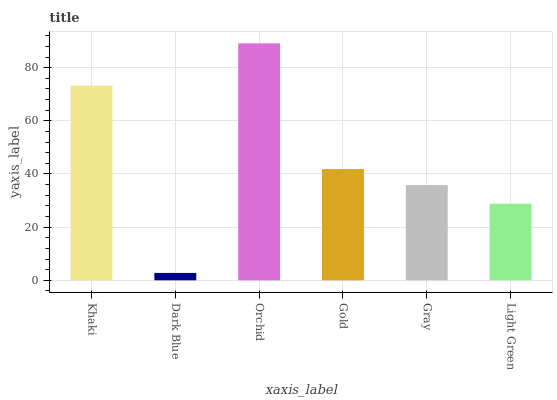Is Dark Blue the minimum?
Answer yes or no. Yes. Is Orchid the maximum?
Answer yes or no. Yes. Is Orchid the minimum?
Answer yes or no. No. Is Dark Blue the maximum?
Answer yes or no. No. Is Orchid greater than Dark Blue?
Answer yes or no. Yes. Is Dark Blue less than Orchid?
Answer yes or no. Yes. Is Dark Blue greater than Orchid?
Answer yes or no. No. Is Orchid less than Dark Blue?
Answer yes or no. No. Is Gold the high median?
Answer yes or no. Yes. Is Gray the low median?
Answer yes or no. Yes. Is Orchid the high median?
Answer yes or no. No. Is Light Green the low median?
Answer yes or no. No. 